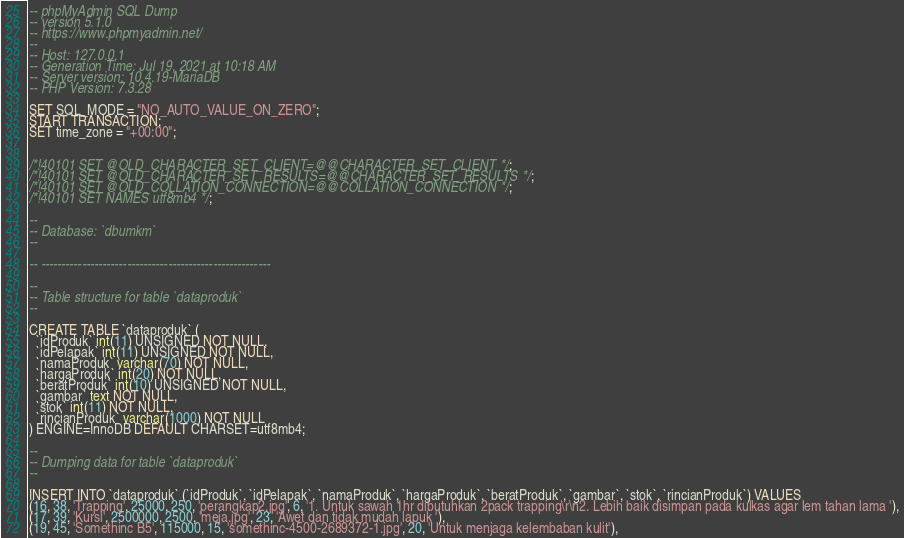Convert code to text. <code><loc_0><loc_0><loc_500><loc_500><_SQL_>-- phpMyAdmin SQL Dump
-- version 5.1.0
-- https://www.phpmyadmin.net/
--
-- Host: 127.0.0.1
-- Generation Time: Jul 19, 2021 at 10:18 AM
-- Server version: 10.4.19-MariaDB
-- PHP Version: 7.3.28

SET SQL_MODE = "NO_AUTO_VALUE_ON_ZERO";
START TRANSACTION;
SET time_zone = "+00:00";


/*!40101 SET @OLD_CHARACTER_SET_CLIENT=@@CHARACTER_SET_CLIENT */;
/*!40101 SET @OLD_CHARACTER_SET_RESULTS=@@CHARACTER_SET_RESULTS */;
/*!40101 SET @OLD_COLLATION_CONNECTION=@@COLLATION_CONNECTION */;
/*!40101 SET NAMES utf8mb4 */;

--
-- Database: `dbumkm`
--

-- --------------------------------------------------------

--
-- Table structure for table `dataproduk`
--

CREATE TABLE `dataproduk` (
  `idProduk` int(11) UNSIGNED NOT NULL,
  `idPelapak` int(11) UNSIGNED NOT NULL,
  `namaProduk` varchar(70) NOT NULL,
  `hargaProduk` int(20) NOT NULL,
  `beratProduk` int(10) UNSIGNED NOT NULL,
  `gambar` text NOT NULL,
  `stok` int(11) NOT NULL,
  `rincianProduk` varchar(1000) NOT NULL
) ENGINE=InnoDB DEFAULT CHARSET=utf8mb4;

--
-- Dumping data for table `dataproduk`
--

INSERT INTO `dataproduk` (`idProduk`, `idPelapak`, `namaProduk`, `hargaProduk`, `beratProduk`, `gambar`, `stok`, `rincianProduk`) VALUES
(16, 38, 'Trapping', 25000, 250, 'perangkap2.jpg', 6, '1. Untuk sawah 1hr dibutuhkan 2pack trapping\r\n2. Lebih baik disimpan pada kulkas agar lem tahan lama '),
(17, 39, 'Kursi', 2500000, 2500, 'meja.jpg', 23, 'Awet dan tidak mudah lapuk '),
(19, 45, 'Somethinc B5', 115000, 15, 'somethinc-4500-2689372-1.jpg', 20, 'Untuk menjaga kelembaban kulit'),</code> 